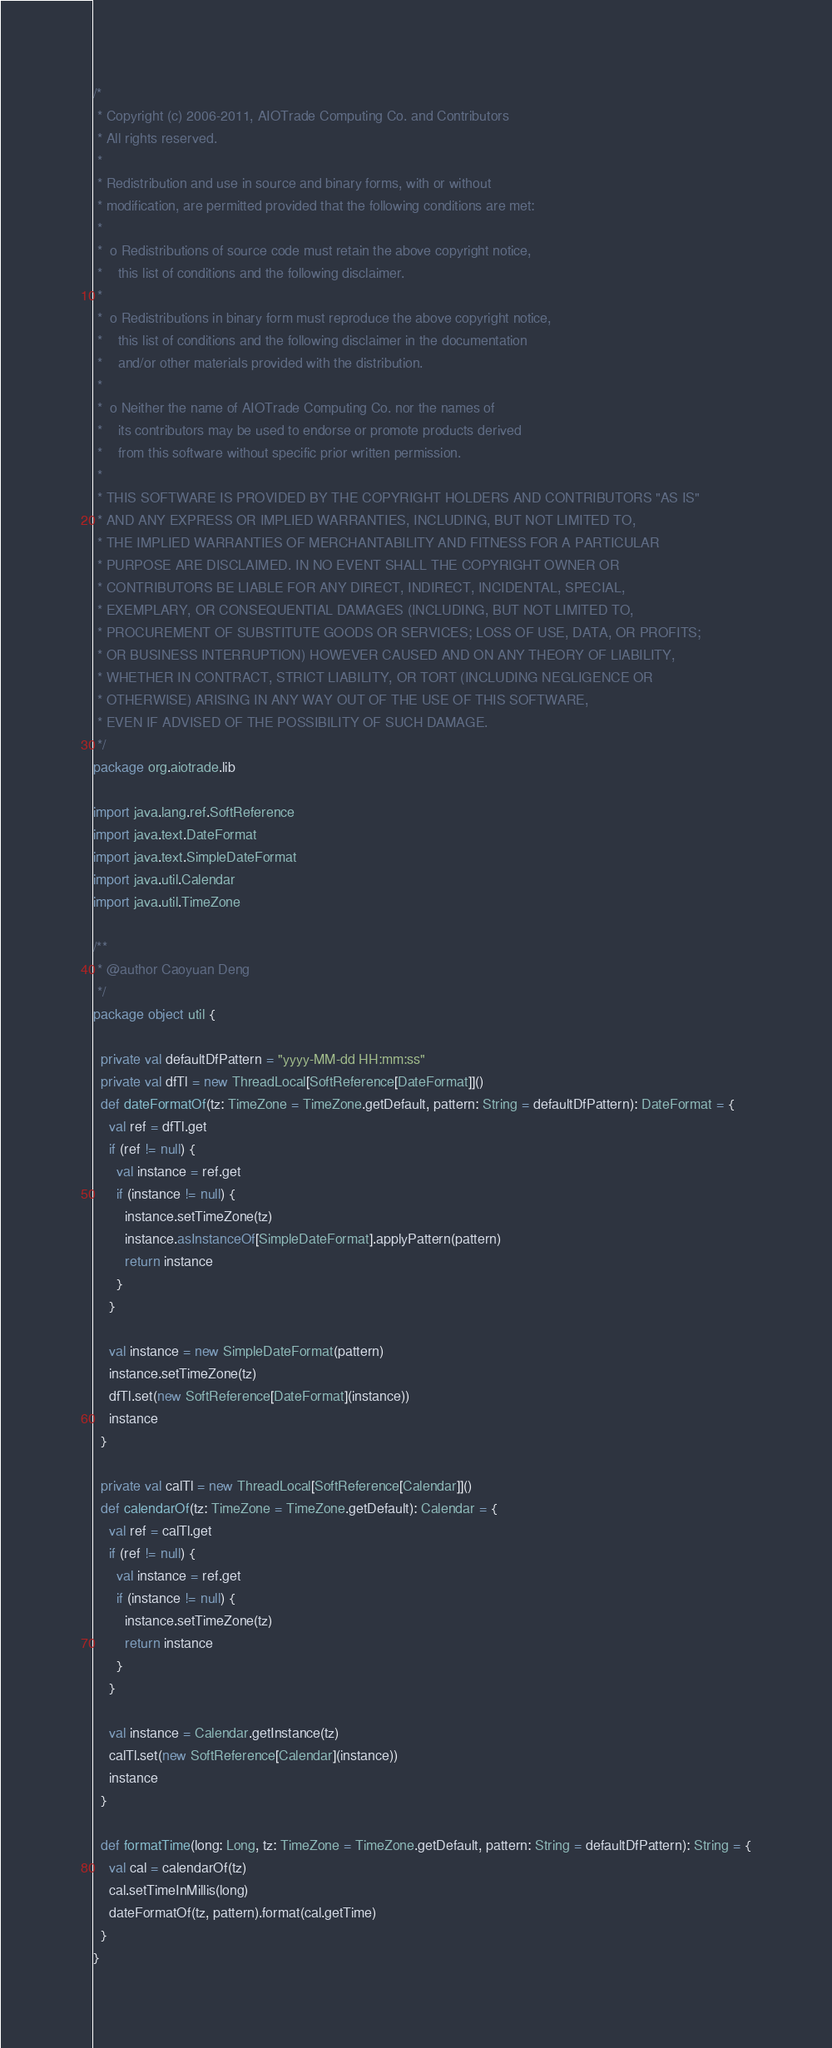<code> <loc_0><loc_0><loc_500><loc_500><_Scala_>/*
 * Copyright (c) 2006-2011, AIOTrade Computing Co. and Contributors
 * All rights reserved.
 * 
 * Redistribution and use in source and binary forms, with or without 
 * modification, are permitted provided that the following conditions are met:
 * 
 *  o Redistributions of source code must retain the above copyright notice, 
 *    this list of conditions and the following disclaimer. 
 *    
 *  o Redistributions in binary form must reproduce the above copyright notice, 
 *    this list of conditions and the following disclaimer in the documentation 
 *    and/or other materials provided with the distribution. 
 *    
 *  o Neither the name of AIOTrade Computing Co. nor the names of 
 *    its contributors may be used to endorse or promote products derived 
 *    from this software without specific prior written permission. 
 *    
 * THIS SOFTWARE IS PROVIDED BY THE COPYRIGHT HOLDERS AND CONTRIBUTORS "AS IS" 
 * AND ANY EXPRESS OR IMPLIED WARRANTIES, INCLUDING, BUT NOT LIMITED TO, 
 * THE IMPLIED WARRANTIES OF MERCHANTABILITY AND FITNESS FOR A PARTICULAR 
 * PURPOSE ARE DISCLAIMED. IN NO EVENT SHALL THE COPYRIGHT OWNER OR 
 * CONTRIBUTORS BE LIABLE FOR ANY DIRECT, INDIRECT, INCIDENTAL, SPECIAL, 
 * EXEMPLARY, OR CONSEQUENTIAL DAMAGES (INCLUDING, BUT NOT LIMITED TO, 
 * PROCUREMENT OF SUBSTITUTE GOODS OR SERVICES; LOSS OF USE, DATA, OR PROFITS; 
 * OR BUSINESS INTERRUPTION) HOWEVER CAUSED AND ON ANY THEORY OF LIABILITY, 
 * WHETHER IN CONTRACT, STRICT LIABILITY, OR TORT (INCLUDING NEGLIGENCE OR 
 * OTHERWISE) ARISING IN ANY WAY OUT OF THE USE OF THIS SOFTWARE, 
 * EVEN IF ADVISED OF THE POSSIBILITY OF SUCH DAMAGE.
 */
package org.aiotrade.lib

import java.lang.ref.SoftReference
import java.text.DateFormat
import java.text.SimpleDateFormat
import java.util.Calendar
import java.util.TimeZone

/**
 * @author Caoyuan Deng
 */
package object util {

  private val defaultDfPattern = "yyyy-MM-dd HH:mm:ss"
  private val dfTl = new ThreadLocal[SoftReference[DateFormat]]()
  def dateFormatOf(tz: TimeZone = TimeZone.getDefault, pattern: String = defaultDfPattern): DateFormat = {
    val ref = dfTl.get
    if (ref != null) {
      val instance = ref.get
      if (instance != null) {
        instance.setTimeZone(tz)
        instance.asInstanceOf[SimpleDateFormat].applyPattern(pattern)
        return instance
      }
    } 
    
    val instance = new SimpleDateFormat(pattern)
    instance.setTimeZone(tz)
    dfTl.set(new SoftReference[DateFormat](instance))
    instance  
  }
  
  private val calTl = new ThreadLocal[SoftReference[Calendar]]()
  def calendarOf(tz: TimeZone = TimeZone.getDefault): Calendar = {
    val ref = calTl.get
    if (ref != null) {
      val instance = ref.get
      if (instance != null) {
        instance.setTimeZone(tz)
        return instance
      }
    }
    
    val instance = Calendar.getInstance(tz)
    calTl.set(new SoftReference[Calendar](instance))
    instance
  }
  
  def formatTime(long: Long, tz: TimeZone = TimeZone.getDefault, pattern: String = defaultDfPattern): String = {
    val cal = calendarOf(tz)
    cal.setTimeInMillis(long)
    dateFormatOf(tz, pattern).format(cal.getTime)
  }
}
</code> 